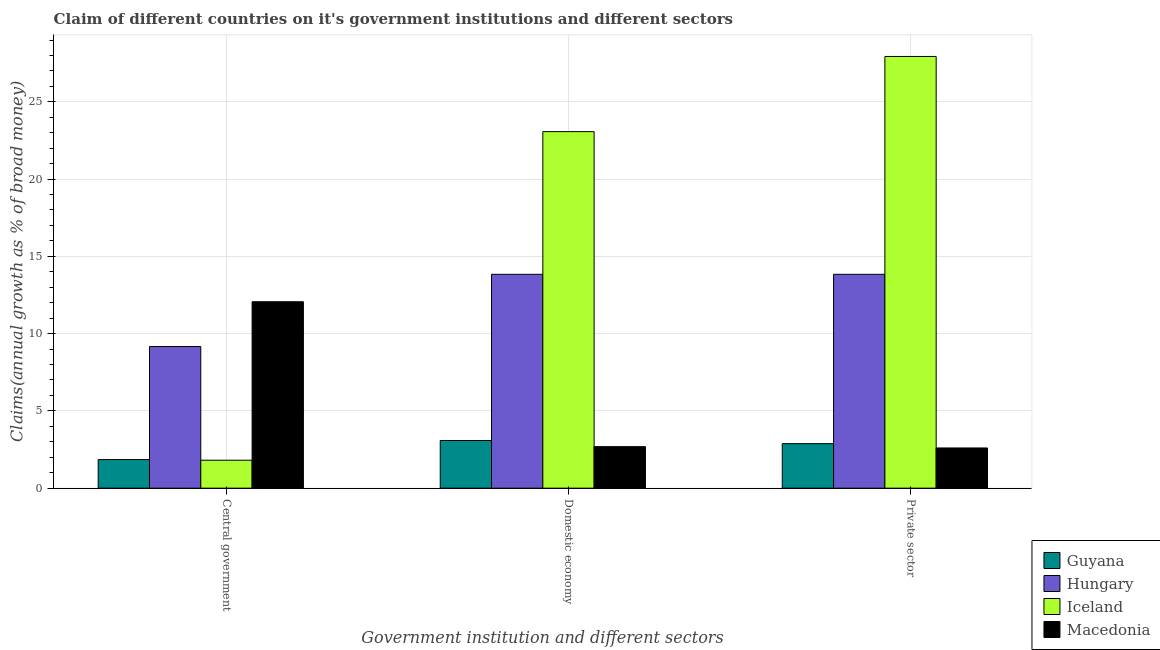Are the number of bars per tick equal to the number of legend labels?
Provide a short and direct response. Yes. How many bars are there on the 2nd tick from the left?
Your response must be concise. 4. What is the label of the 1st group of bars from the left?
Offer a very short reply. Central government. What is the percentage of claim on the private sector in Iceland?
Offer a very short reply. 27.94. Across all countries, what is the maximum percentage of claim on the domestic economy?
Ensure brevity in your answer.  23.07. Across all countries, what is the minimum percentage of claim on the private sector?
Your response must be concise. 2.6. In which country was the percentage of claim on the domestic economy maximum?
Your answer should be compact. Iceland. What is the total percentage of claim on the private sector in the graph?
Offer a very short reply. 47.25. What is the difference between the percentage of claim on the domestic economy in Guyana and that in Hungary?
Your answer should be compact. -10.75. What is the difference between the percentage of claim on the private sector in Macedonia and the percentage of claim on the central government in Iceland?
Offer a terse response. 0.79. What is the average percentage of claim on the private sector per country?
Offer a terse response. 11.81. What is the difference between the percentage of claim on the central government and percentage of claim on the private sector in Macedonia?
Provide a short and direct response. 9.46. What is the ratio of the percentage of claim on the central government in Macedonia to that in Guyana?
Your answer should be compact. 6.52. Is the percentage of claim on the domestic economy in Hungary less than that in Guyana?
Offer a terse response. No. What is the difference between the highest and the second highest percentage of claim on the central government?
Provide a succinct answer. 2.9. What is the difference between the highest and the lowest percentage of claim on the private sector?
Offer a terse response. 25.33. In how many countries, is the percentage of claim on the private sector greater than the average percentage of claim on the private sector taken over all countries?
Keep it short and to the point. 2. What does the 4th bar from the left in Domestic economy represents?
Provide a short and direct response. Macedonia. What does the 4th bar from the right in Central government represents?
Provide a succinct answer. Guyana. Is it the case that in every country, the sum of the percentage of claim on the central government and percentage of claim on the domestic economy is greater than the percentage of claim on the private sector?
Ensure brevity in your answer.  No. How many bars are there?
Offer a terse response. 12. How many countries are there in the graph?
Your response must be concise. 4. What is the difference between two consecutive major ticks on the Y-axis?
Offer a very short reply. 5. Does the graph contain any zero values?
Your response must be concise. No. Does the graph contain grids?
Your answer should be compact. Yes. How many legend labels are there?
Keep it short and to the point. 4. What is the title of the graph?
Ensure brevity in your answer.  Claim of different countries on it's government institutions and different sectors. Does "Mali" appear as one of the legend labels in the graph?
Your response must be concise. No. What is the label or title of the X-axis?
Offer a very short reply. Government institution and different sectors. What is the label or title of the Y-axis?
Provide a succinct answer. Claims(annual growth as % of broad money). What is the Claims(annual growth as % of broad money) in Guyana in Central government?
Your answer should be compact. 1.85. What is the Claims(annual growth as % of broad money) of Hungary in Central government?
Keep it short and to the point. 9.16. What is the Claims(annual growth as % of broad money) of Iceland in Central government?
Provide a succinct answer. 1.81. What is the Claims(annual growth as % of broad money) of Macedonia in Central government?
Make the answer very short. 12.06. What is the Claims(annual growth as % of broad money) in Guyana in Domestic economy?
Give a very brief answer. 3.08. What is the Claims(annual growth as % of broad money) in Hungary in Domestic economy?
Your response must be concise. 13.84. What is the Claims(annual growth as % of broad money) in Iceland in Domestic economy?
Offer a terse response. 23.07. What is the Claims(annual growth as % of broad money) of Macedonia in Domestic economy?
Make the answer very short. 2.68. What is the Claims(annual growth as % of broad money) of Guyana in Private sector?
Give a very brief answer. 2.88. What is the Claims(annual growth as % of broad money) of Hungary in Private sector?
Your answer should be compact. 13.84. What is the Claims(annual growth as % of broad money) of Iceland in Private sector?
Offer a terse response. 27.94. What is the Claims(annual growth as % of broad money) of Macedonia in Private sector?
Give a very brief answer. 2.6. Across all Government institution and different sectors, what is the maximum Claims(annual growth as % of broad money) of Guyana?
Ensure brevity in your answer.  3.08. Across all Government institution and different sectors, what is the maximum Claims(annual growth as % of broad money) in Hungary?
Offer a terse response. 13.84. Across all Government institution and different sectors, what is the maximum Claims(annual growth as % of broad money) of Iceland?
Your response must be concise. 27.94. Across all Government institution and different sectors, what is the maximum Claims(annual growth as % of broad money) of Macedonia?
Provide a succinct answer. 12.06. Across all Government institution and different sectors, what is the minimum Claims(annual growth as % of broad money) in Guyana?
Keep it short and to the point. 1.85. Across all Government institution and different sectors, what is the minimum Claims(annual growth as % of broad money) in Hungary?
Your response must be concise. 9.16. Across all Government institution and different sectors, what is the minimum Claims(annual growth as % of broad money) of Iceland?
Your answer should be compact. 1.81. Across all Government institution and different sectors, what is the minimum Claims(annual growth as % of broad money) of Macedonia?
Offer a terse response. 2.6. What is the total Claims(annual growth as % of broad money) in Guyana in the graph?
Your response must be concise. 7.81. What is the total Claims(annual growth as % of broad money) in Hungary in the graph?
Your answer should be compact. 36.84. What is the total Claims(annual growth as % of broad money) in Iceland in the graph?
Ensure brevity in your answer.  52.81. What is the total Claims(annual growth as % of broad money) in Macedonia in the graph?
Provide a short and direct response. 17.35. What is the difference between the Claims(annual growth as % of broad money) of Guyana in Central government and that in Domestic economy?
Keep it short and to the point. -1.23. What is the difference between the Claims(annual growth as % of broad money) of Hungary in Central government and that in Domestic economy?
Your answer should be very brief. -4.67. What is the difference between the Claims(annual growth as % of broad money) in Iceland in Central government and that in Domestic economy?
Make the answer very short. -21.26. What is the difference between the Claims(annual growth as % of broad money) of Macedonia in Central government and that in Domestic economy?
Keep it short and to the point. 9.38. What is the difference between the Claims(annual growth as % of broad money) in Guyana in Central government and that in Private sector?
Make the answer very short. -1.03. What is the difference between the Claims(annual growth as % of broad money) of Hungary in Central government and that in Private sector?
Your answer should be compact. -4.67. What is the difference between the Claims(annual growth as % of broad money) in Iceland in Central government and that in Private sector?
Offer a terse response. -26.13. What is the difference between the Claims(annual growth as % of broad money) of Macedonia in Central government and that in Private sector?
Ensure brevity in your answer.  9.46. What is the difference between the Claims(annual growth as % of broad money) of Guyana in Domestic economy and that in Private sector?
Your response must be concise. 0.2. What is the difference between the Claims(annual growth as % of broad money) in Iceland in Domestic economy and that in Private sector?
Your response must be concise. -4.86. What is the difference between the Claims(annual growth as % of broad money) in Macedonia in Domestic economy and that in Private sector?
Offer a terse response. 0.08. What is the difference between the Claims(annual growth as % of broad money) in Guyana in Central government and the Claims(annual growth as % of broad money) in Hungary in Domestic economy?
Keep it short and to the point. -11.99. What is the difference between the Claims(annual growth as % of broad money) of Guyana in Central government and the Claims(annual growth as % of broad money) of Iceland in Domestic economy?
Your answer should be compact. -21.22. What is the difference between the Claims(annual growth as % of broad money) of Guyana in Central government and the Claims(annual growth as % of broad money) of Macedonia in Domestic economy?
Offer a very short reply. -0.83. What is the difference between the Claims(annual growth as % of broad money) of Hungary in Central government and the Claims(annual growth as % of broad money) of Iceland in Domestic economy?
Offer a very short reply. -13.91. What is the difference between the Claims(annual growth as % of broad money) in Hungary in Central government and the Claims(annual growth as % of broad money) in Macedonia in Domestic economy?
Keep it short and to the point. 6.48. What is the difference between the Claims(annual growth as % of broad money) in Iceland in Central government and the Claims(annual growth as % of broad money) in Macedonia in Domestic economy?
Your answer should be compact. -0.88. What is the difference between the Claims(annual growth as % of broad money) in Guyana in Central government and the Claims(annual growth as % of broad money) in Hungary in Private sector?
Your answer should be compact. -11.99. What is the difference between the Claims(annual growth as % of broad money) in Guyana in Central government and the Claims(annual growth as % of broad money) in Iceland in Private sector?
Provide a short and direct response. -26.09. What is the difference between the Claims(annual growth as % of broad money) of Guyana in Central government and the Claims(annual growth as % of broad money) of Macedonia in Private sector?
Keep it short and to the point. -0.75. What is the difference between the Claims(annual growth as % of broad money) of Hungary in Central government and the Claims(annual growth as % of broad money) of Iceland in Private sector?
Keep it short and to the point. -18.77. What is the difference between the Claims(annual growth as % of broad money) in Hungary in Central government and the Claims(annual growth as % of broad money) in Macedonia in Private sector?
Ensure brevity in your answer.  6.56. What is the difference between the Claims(annual growth as % of broad money) in Iceland in Central government and the Claims(annual growth as % of broad money) in Macedonia in Private sector?
Offer a very short reply. -0.79. What is the difference between the Claims(annual growth as % of broad money) of Guyana in Domestic economy and the Claims(annual growth as % of broad money) of Hungary in Private sector?
Give a very brief answer. -10.75. What is the difference between the Claims(annual growth as % of broad money) of Guyana in Domestic economy and the Claims(annual growth as % of broad money) of Iceland in Private sector?
Your answer should be compact. -24.85. What is the difference between the Claims(annual growth as % of broad money) of Guyana in Domestic economy and the Claims(annual growth as % of broad money) of Macedonia in Private sector?
Give a very brief answer. 0.48. What is the difference between the Claims(annual growth as % of broad money) in Hungary in Domestic economy and the Claims(annual growth as % of broad money) in Iceland in Private sector?
Ensure brevity in your answer.  -14.1. What is the difference between the Claims(annual growth as % of broad money) in Hungary in Domestic economy and the Claims(annual growth as % of broad money) in Macedonia in Private sector?
Give a very brief answer. 11.24. What is the difference between the Claims(annual growth as % of broad money) of Iceland in Domestic economy and the Claims(annual growth as % of broad money) of Macedonia in Private sector?
Your response must be concise. 20.47. What is the average Claims(annual growth as % of broad money) in Guyana per Government institution and different sectors?
Your response must be concise. 2.6. What is the average Claims(annual growth as % of broad money) in Hungary per Government institution and different sectors?
Make the answer very short. 12.28. What is the average Claims(annual growth as % of broad money) of Iceland per Government institution and different sectors?
Provide a short and direct response. 17.6. What is the average Claims(annual growth as % of broad money) of Macedonia per Government institution and different sectors?
Your answer should be very brief. 5.78. What is the difference between the Claims(annual growth as % of broad money) of Guyana and Claims(annual growth as % of broad money) of Hungary in Central government?
Your answer should be very brief. -7.31. What is the difference between the Claims(annual growth as % of broad money) of Guyana and Claims(annual growth as % of broad money) of Iceland in Central government?
Provide a short and direct response. 0.04. What is the difference between the Claims(annual growth as % of broad money) of Guyana and Claims(annual growth as % of broad money) of Macedonia in Central government?
Your answer should be compact. -10.21. What is the difference between the Claims(annual growth as % of broad money) in Hungary and Claims(annual growth as % of broad money) in Iceland in Central government?
Offer a terse response. 7.36. What is the difference between the Claims(annual growth as % of broad money) in Hungary and Claims(annual growth as % of broad money) in Macedonia in Central government?
Give a very brief answer. -2.9. What is the difference between the Claims(annual growth as % of broad money) of Iceland and Claims(annual growth as % of broad money) of Macedonia in Central government?
Ensure brevity in your answer.  -10.25. What is the difference between the Claims(annual growth as % of broad money) in Guyana and Claims(annual growth as % of broad money) in Hungary in Domestic economy?
Ensure brevity in your answer.  -10.75. What is the difference between the Claims(annual growth as % of broad money) in Guyana and Claims(annual growth as % of broad money) in Iceland in Domestic economy?
Provide a short and direct response. -19.99. What is the difference between the Claims(annual growth as % of broad money) of Guyana and Claims(annual growth as % of broad money) of Macedonia in Domestic economy?
Keep it short and to the point. 0.4. What is the difference between the Claims(annual growth as % of broad money) in Hungary and Claims(annual growth as % of broad money) in Iceland in Domestic economy?
Make the answer very short. -9.23. What is the difference between the Claims(annual growth as % of broad money) of Hungary and Claims(annual growth as % of broad money) of Macedonia in Domestic economy?
Give a very brief answer. 11.15. What is the difference between the Claims(annual growth as % of broad money) in Iceland and Claims(annual growth as % of broad money) in Macedonia in Domestic economy?
Your response must be concise. 20.39. What is the difference between the Claims(annual growth as % of broad money) of Guyana and Claims(annual growth as % of broad money) of Hungary in Private sector?
Ensure brevity in your answer.  -10.96. What is the difference between the Claims(annual growth as % of broad money) in Guyana and Claims(annual growth as % of broad money) in Iceland in Private sector?
Your answer should be compact. -25.05. What is the difference between the Claims(annual growth as % of broad money) in Guyana and Claims(annual growth as % of broad money) in Macedonia in Private sector?
Make the answer very short. 0.28. What is the difference between the Claims(annual growth as % of broad money) in Hungary and Claims(annual growth as % of broad money) in Iceland in Private sector?
Offer a very short reply. -14.1. What is the difference between the Claims(annual growth as % of broad money) in Hungary and Claims(annual growth as % of broad money) in Macedonia in Private sector?
Offer a very short reply. 11.24. What is the difference between the Claims(annual growth as % of broad money) in Iceland and Claims(annual growth as % of broad money) in Macedonia in Private sector?
Your answer should be compact. 25.33. What is the ratio of the Claims(annual growth as % of broad money) in Guyana in Central government to that in Domestic economy?
Offer a very short reply. 0.6. What is the ratio of the Claims(annual growth as % of broad money) in Hungary in Central government to that in Domestic economy?
Your response must be concise. 0.66. What is the ratio of the Claims(annual growth as % of broad money) of Iceland in Central government to that in Domestic economy?
Your answer should be very brief. 0.08. What is the ratio of the Claims(annual growth as % of broad money) in Macedonia in Central government to that in Domestic economy?
Your answer should be compact. 4.49. What is the ratio of the Claims(annual growth as % of broad money) of Guyana in Central government to that in Private sector?
Your response must be concise. 0.64. What is the ratio of the Claims(annual growth as % of broad money) of Hungary in Central government to that in Private sector?
Ensure brevity in your answer.  0.66. What is the ratio of the Claims(annual growth as % of broad money) in Iceland in Central government to that in Private sector?
Offer a terse response. 0.06. What is the ratio of the Claims(annual growth as % of broad money) in Macedonia in Central government to that in Private sector?
Offer a terse response. 4.64. What is the ratio of the Claims(annual growth as % of broad money) in Guyana in Domestic economy to that in Private sector?
Your answer should be compact. 1.07. What is the ratio of the Claims(annual growth as % of broad money) of Hungary in Domestic economy to that in Private sector?
Your answer should be very brief. 1. What is the ratio of the Claims(annual growth as % of broad money) of Iceland in Domestic economy to that in Private sector?
Make the answer very short. 0.83. What is the ratio of the Claims(annual growth as % of broad money) in Macedonia in Domestic economy to that in Private sector?
Provide a short and direct response. 1.03. What is the difference between the highest and the second highest Claims(annual growth as % of broad money) of Guyana?
Offer a very short reply. 0.2. What is the difference between the highest and the second highest Claims(annual growth as % of broad money) of Hungary?
Offer a very short reply. 0. What is the difference between the highest and the second highest Claims(annual growth as % of broad money) in Iceland?
Your answer should be very brief. 4.86. What is the difference between the highest and the second highest Claims(annual growth as % of broad money) in Macedonia?
Your answer should be compact. 9.38. What is the difference between the highest and the lowest Claims(annual growth as % of broad money) in Guyana?
Your answer should be very brief. 1.23. What is the difference between the highest and the lowest Claims(annual growth as % of broad money) in Hungary?
Keep it short and to the point. 4.67. What is the difference between the highest and the lowest Claims(annual growth as % of broad money) of Iceland?
Offer a terse response. 26.13. What is the difference between the highest and the lowest Claims(annual growth as % of broad money) of Macedonia?
Provide a succinct answer. 9.46. 